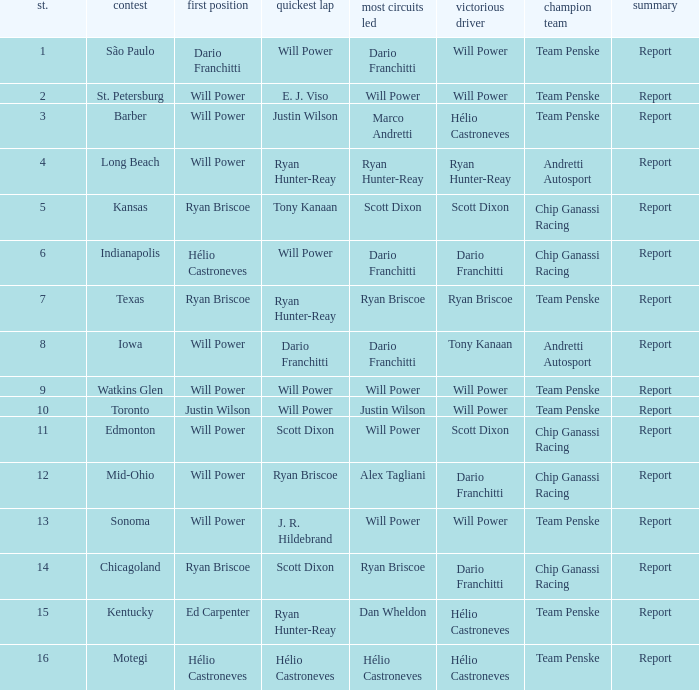Who was on the pole at Chicagoland? Ryan Briscoe. Give me the full table as a dictionary. {'header': ['st.', 'contest', 'first position', 'quickest lap', 'most circuits led', 'victorious driver', 'champion team', 'summary'], 'rows': [['1', 'São Paulo', 'Dario Franchitti', 'Will Power', 'Dario Franchitti', 'Will Power', 'Team Penske', 'Report'], ['2', 'St. Petersburg', 'Will Power', 'E. J. Viso', 'Will Power', 'Will Power', 'Team Penske', 'Report'], ['3', 'Barber', 'Will Power', 'Justin Wilson', 'Marco Andretti', 'Hélio Castroneves', 'Team Penske', 'Report'], ['4', 'Long Beach', 'Will Power', 'Ryan Hunter-Reay', 'Ryan Hunter-Reay', 'Ryan Hunter-Reay', 'Andretti Autosport', 'Report'], ['5', 'Kansas', 'Ryan Briscoe', 'Tony Kanaan', 'Scott Dixon', 'Scott Dixon', 'Chip Ganassi Racing', 'Report'], ['6', 'Indianapolis', 'Hélio Castroneves', 'Will Power', 'Dario Franchitti', 'Dario Franchitti', 'Chip Ganassi Racing', 'Report'], ['7', 'Texas', 'Ryan Briscoe', 'Ryan Hunter-Reay', 'Ryan Briscoe', 'Ryan Briscoe', 'Team Penske', 'Report'], ['8', 'Iowa', 'Will Power', 'Dario Franchitti', 'Dario Franchitti', 'Tony Kanaan', 'Andretti Autosport', 'Report'], ['9', 'Watkins Glen', 'Will Power', 'Will Power', 'Will Power', 'Will Power', 'Team Penske', 'Report'], ['10', 'Toronto', 'Justin Wilson', 'Will Power', 'Justin Wilson', 'Will Power', 'Team Penske', 'Report'], ['11', 'Edmonton', 'Will Power', 'Scott Dixon', 'Will Power', 'Scott Dixon', 'Chip Ganassi Racing', 'Report'], ['12', 'Mid-Ohio', 'Will Power', 'Ryan Briscoe', 'Alex Tagliani', 'Dario Franchitti', 'Chip Ganassi Racing', 'Report'], ['13', 'Sonoma', 'Will Power', 'J. R. Hildebrand', 'Will Power', 'Will Power', 'Team Penske', 'Report'], ['14', 'Chicagoland', 'Ryan Briscoe', 'Scott Dixon', 'Ryan Briscoe', 'Dario Franchitti', 'Chip Ganassi Racing', 'Report'], ['15', 'Kentucky', 'Ed Carpenter', 'Ryan Hunter-Reay', 'Dan Wheldon', 'Hélio Castroneves', 'Team Penske', 'Report'], ['16', 'Motegi', 'Hélio Castroneves', 'Hélio Castroneves', 'Hélio Castroneves', 'Hélio Castroneves', 'Team Penske', 'Report']]} 